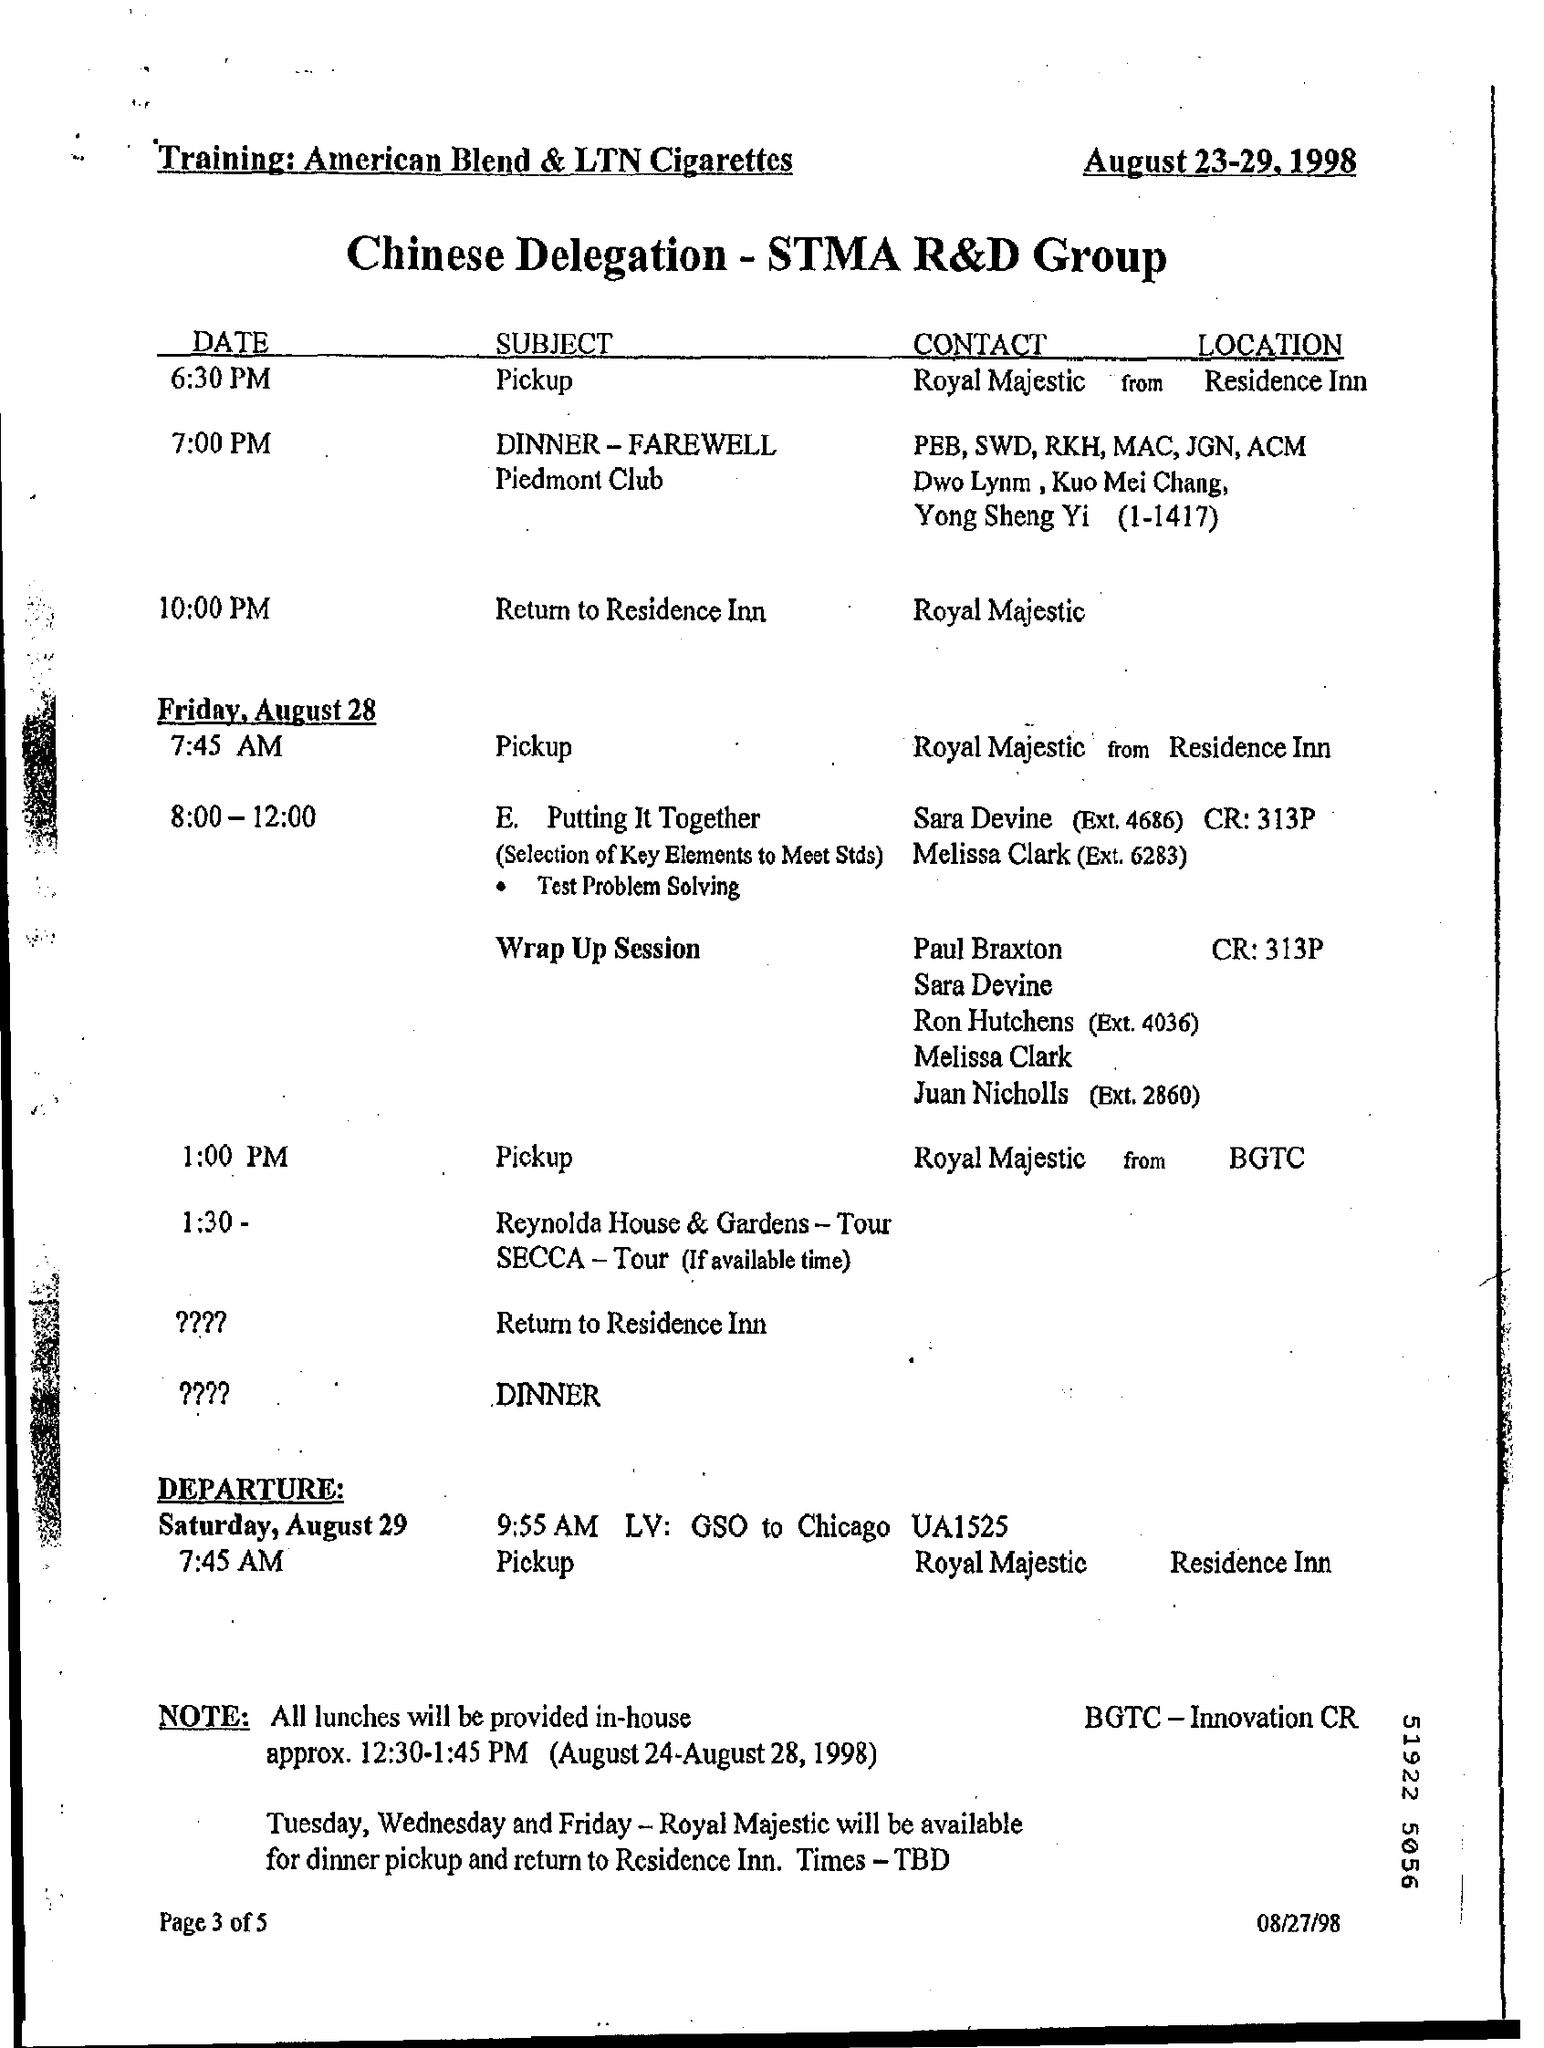Draw attention to some important aspects in this diagram. The event scheduled for Friday August 28 at 7:45 AM concerns pickup. The date mentioned at the top is August 23-29, 1998. 